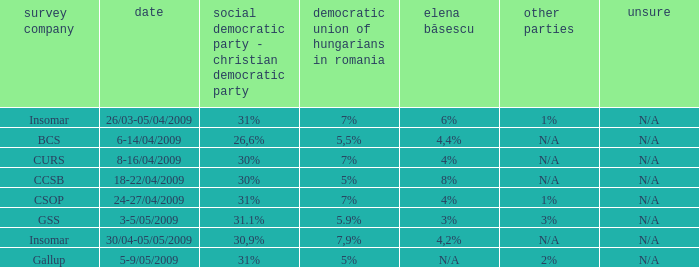When the other is n/a and the psc-pc is 30% what is the date? 8-16/04/2009, 18-22/04/2009. 